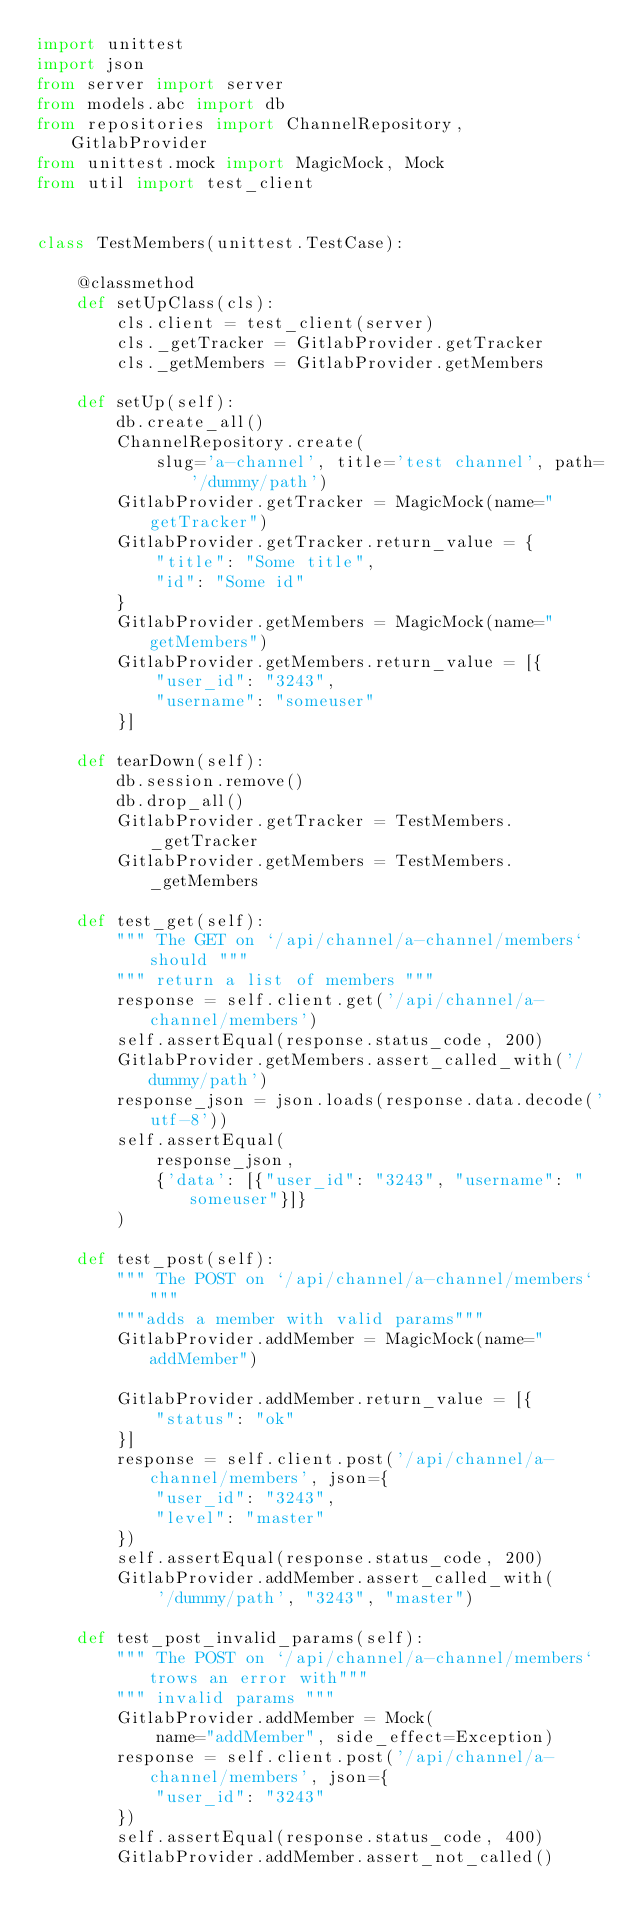Convert code to text. <code><loc_0><loc_0><loc_500><loc_500><_Python_>import unittest
import json
from server import server
from models.abc import db
from repositories import ChannelRepository, GitlabProvider
from unittest.mock import MagicMock, Mock
from util import test_client


class TestMembers(unittest.TestCase):

    @classmethod
    def setUpClass(cls):
        cls.client = test_client(server)
        cls._getTracker = GitlabProvider.getTracker
        cls._getMembers = GitlabProvider.getMembers

    def setUp(self):
        db.create_all()
        ChannelRepository.create(
            slug='a-channel', title='test channel', path='/dummy/path')
        GitlabProvider.getTracker = MagicMock(name="getTracker")
        GitlabProvider.getTracker.return_value = {
            "title": "Some title",
            "id": "Some id"
        }
        GitlabProvider.getMembers = MagicMock(name="getMembers")
        GitlabProvider.getMembers.return_value = [{
            "user_id": "3243",
            "username": "someuser"
        }]

    def tearDown(self):
        db.session.remove()
        db.drop_all()
        GitlabProvider.getTracker = TestMembers._getTracker
        GitlabProvider.getMembers = TestMembers._getMembers

    def test_get(self):
        """ The GET on `/api/channel/a-channel/members` should """
        """ return a list of members """
        response = self.client.get('/api/channel/a-channel/members')
        self.assertEqual(response.status_code, 200)
        GitlabProvider.getMembers.assert_called_with('/dummy/path')
        response_json = json.loads(response.data.decode('utf-8'))
        self.assertEqual(
            response_json,
            {'data': [{"user_id": "3243", "username": "someuser"}]}
        )

    def test_post(self):
        """ The POST on `/api/channel/a-channel/members` """
        """adds a member with valid params"""
        GitlabProvider.addMember = MagicMock(name="addMember")

        GitlabProvider.addMember.return_value = [{
            "status": "ok"
        }]
        response = self.client.post('/api/channel/a-channel/members', json={
            "user_id": "3243",
            "level": "master"
        })
        self.assertEqual(response.status_code, 200)
        GitlabProvider.addMember.assert_called_with(
            '/dummy/path', "3243", "master")

    def test_post_invalid_params(self):
        """ The POST on `/api/channel/a-channel/members` trows an error with"""
        """ invalid params """
        GitlabProvider.addMember = Mock(
            name="addMember", side_effect=Exception)
        response = self.client.post('/api/channel/a-channel/members', json={
            "user_id": "3243"
        })
        self.assertEqual(response.status_code, 400)
        GitlabProvider.addMember.assert_not_called()
</code> 